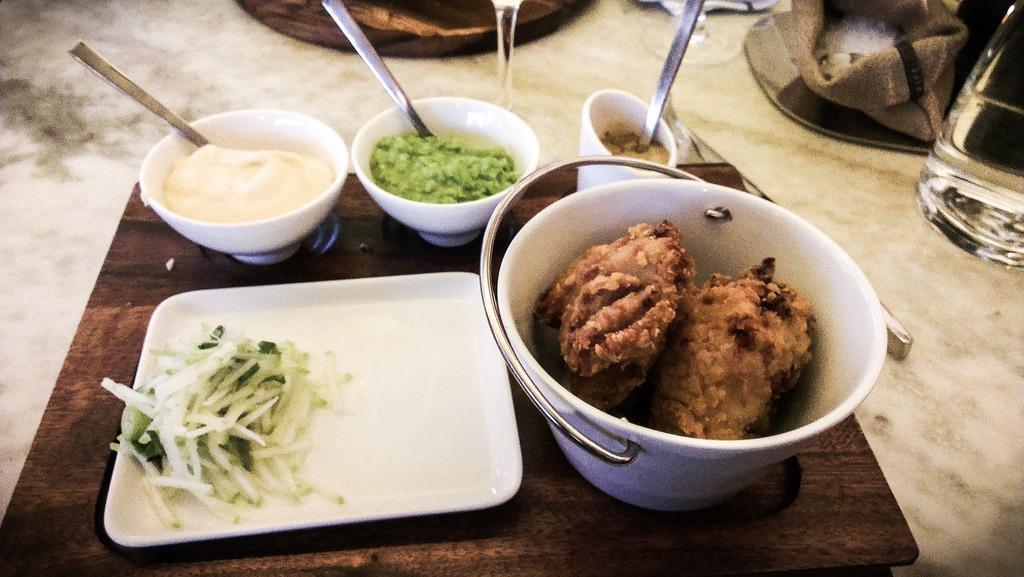Can you describe this image briefly? In this picture I see a brown color board on which there are cups, a plate and a bucket in which there is food and I see the spoons. In the background I see a glass, a bottle and few more things. 